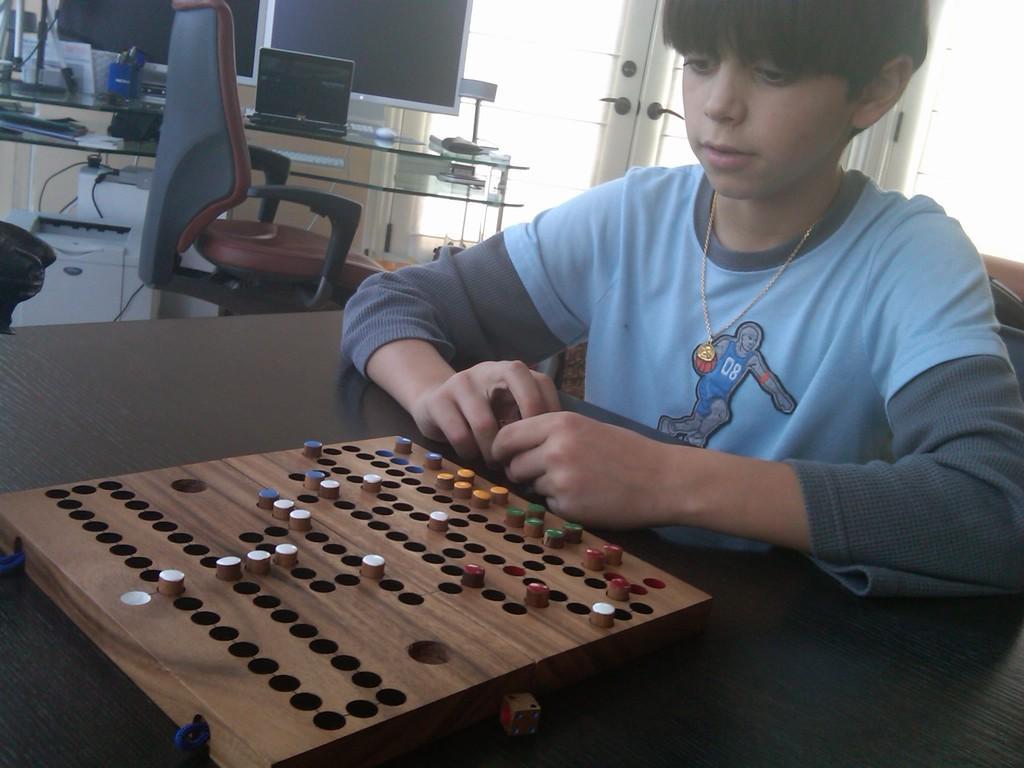How would you summarize this image in a sentence or two? In this image we can see a child wearing blue T-shirt is sitting near the wooden table where a game board is placed. In the background, we can see printer, laptop, monitors, mouse, keyboard and a few more things kept here. Here we can see the glass doors. 